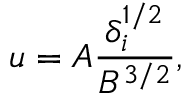<formula> <loc_0><loc_0><loc_500><loc_500>u = A \frac { \delta _ { i } ^ { 1 / 2 } } { B ^ { 3 / 2 } } ,</formula> 